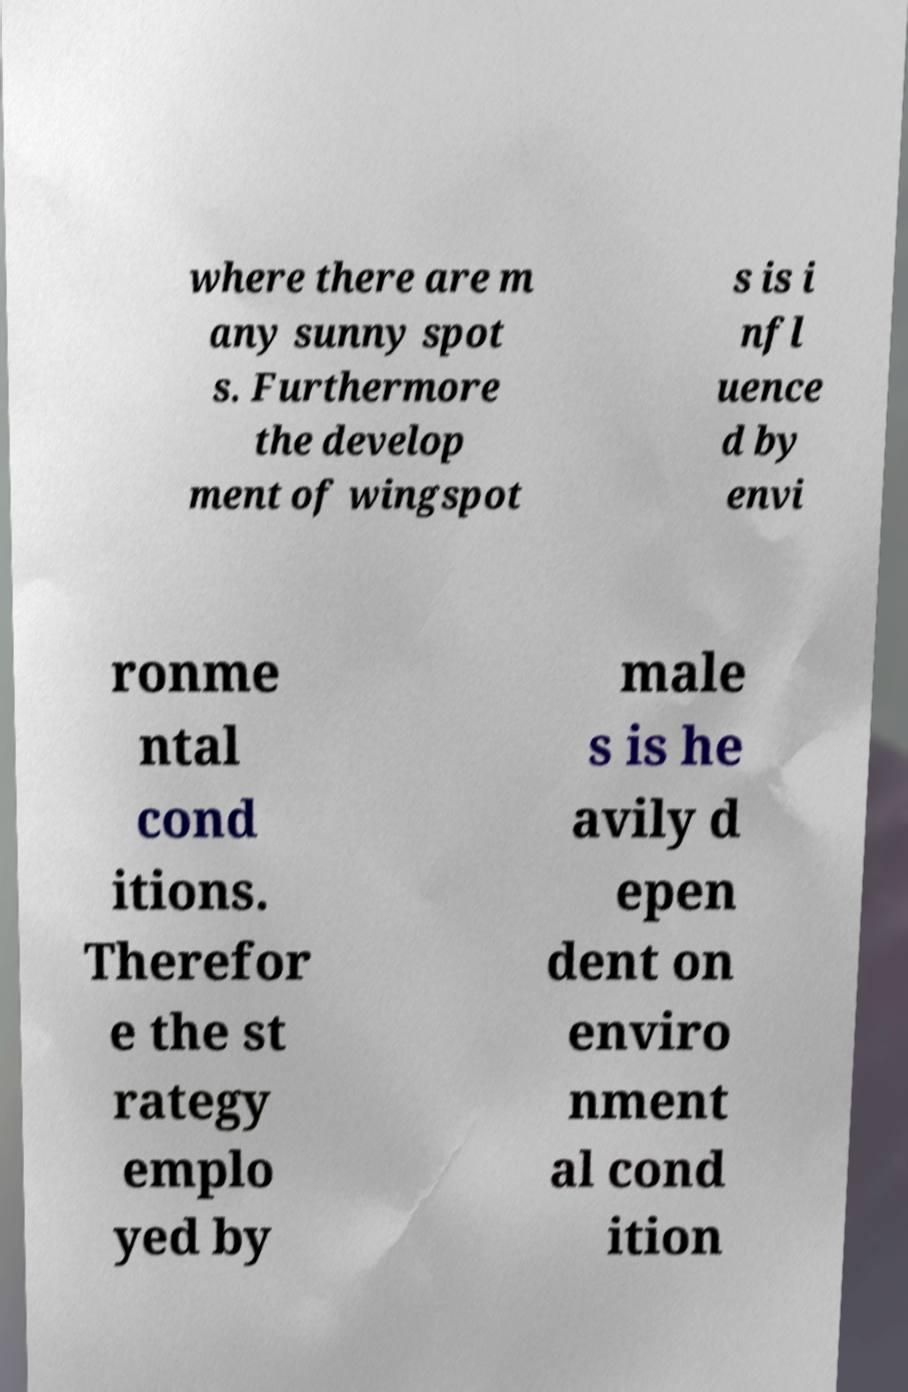Can you accurately transcribe the text from the provided image for me? where there are m any sunny spot s. Furthermore the develop ment of wingspot s is i nfl uence d by envi ronme ntal cond itions. Therefor e the st rategy emplo yed by male s is he avily d epen dent on enviro nment al cond ition 